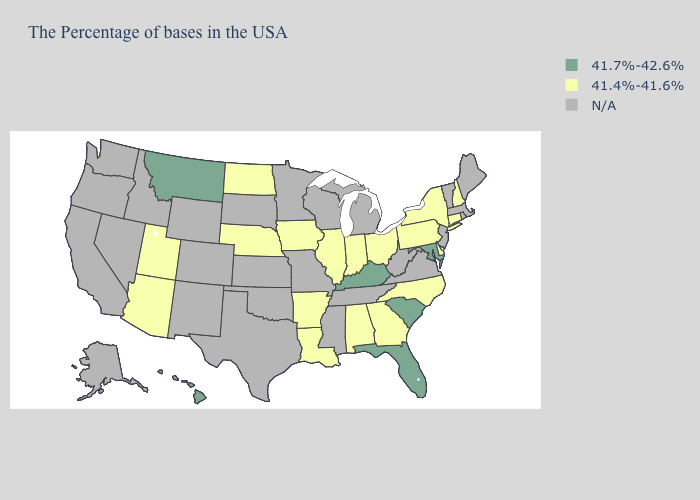What is the value of Massachusetts?
Write a very short answer. N/A. What is the highest value in the South ?
Short answer required. 41.7%-42.6%. What is the value of Missouri?
Be succinct. N/A. Among the states that border Virginia , which have the lowest value?
Be succinct. North Carolina. Name the states that have a value in the range N/A?
Give a very brief answer. Maine, Massachusetts, Rhode Island, Vermont, New Jersey, Virginia, West Virginia, Michigan, Tennessee, Wisconsin, Mississippi, Missouri, Minnesota, Kansas, Oklahoma, Texas, South Dakota, Wyoming, Colorado, New Mexico, Idaho, Nevada, California, Washington, Oregon, Alaska. What is the value of Delaware?
Quick response, please. 41.4%-41.6%. Name the states that have a value in the range 41.4%-41.6%?
Give a very brief answer. New Hampshire, Connecticut, New York, Delaware, Pennsylvania, North Carolina, Ohio, Georgia, Indiana, Alabama, Illinois, Louisiana, Arkansas, Iowa, Nebraska, North Dakota, Utah, Arizona. How many symbols are there in the legend?
Keep it brief. 3. Does Utah have the lowest value in the West?
Concise answer only. Yes. How many symbols are there in the legend?
Give a very brief answer. 3. Name the states that have a value in the range 41.7%-42.6%?
Write a very short answer. Maryland, South Carolina, Florida, Kentucky, Montana, Hawaii. What is the value of Hawaii?
Write a very short answer. 41.7%-42.6%. Which states have the highest value in the USA?
Write a very short answer. Maryland, South Carolina, Florida, Kentucky, Montana, Hawaii. 